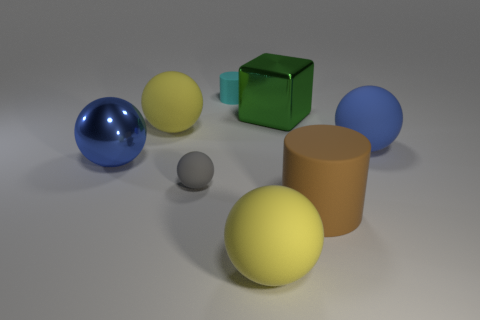Subtract all blue matte balls. How many balls are left? 4 Add 1 large green cubes. How many objects exist? 9 Subtract all brown cylinders. How many cylinders are left? 1 Subtract 1 cubes. How many cubes are left? 0 Subtract all blocks. How many objects are left? 7 Subtract all blue cylinders. Subtract all purple balls. How many cylinders are left? 2 Subtract all green spheres. How many cyan cylinders are left? 1 Subtract all small brown objects. Subtract all blue rubber spheres. How many objects are left? 7 Add 8 large blue rubber spheres. How many large blue rubber spheres are left? 9 Add 2 gray objects. How many gray objects exist? 3 